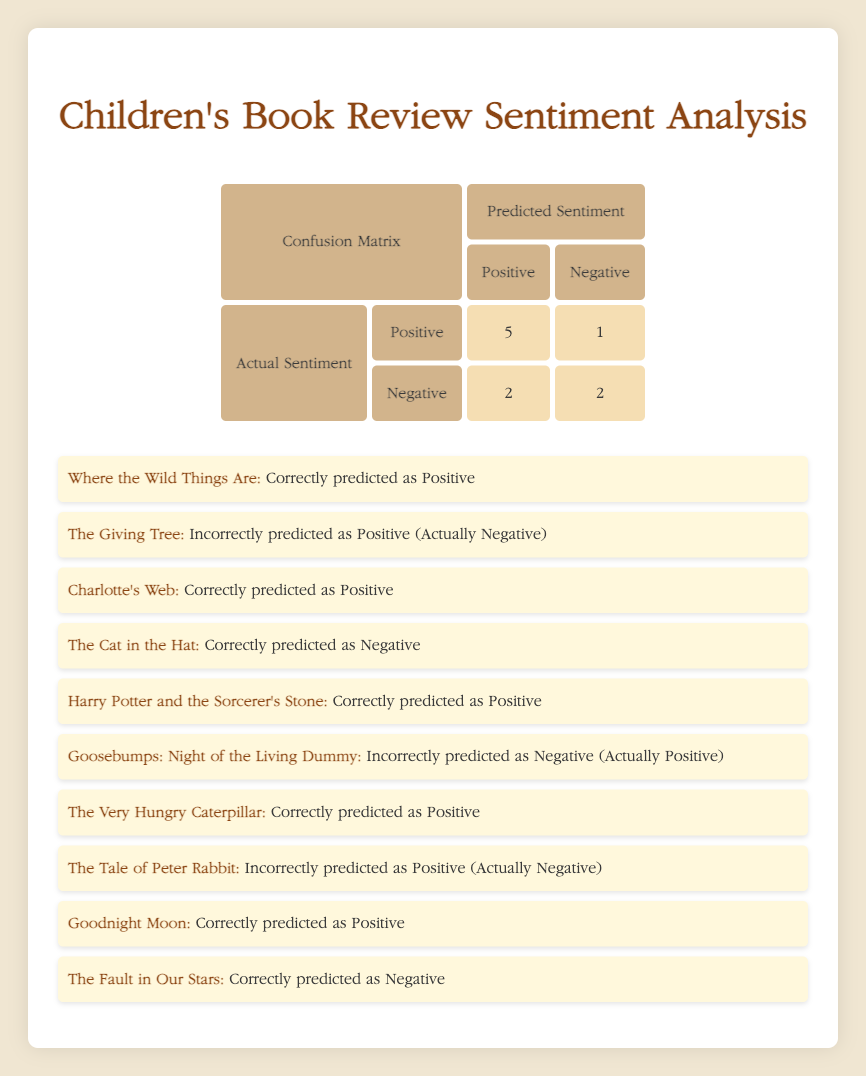What is the number of true positives in the confusion matrix? The confusion matrix shows 5 true positives, which means there are 5 instances where the predicted sentiment was positive and the actual sentiment was also positive.
Answer: 5 How many books were incorrectly predicted as having a positive sentiment? From the table, there are 2 instances where the actual sentiment was negative but predicted sentiment was positive: The Giving Tree and The Tale of Peter Rabbit.
Answer: 2 What is the total number of negative reviews? Looking at the "Actual Sentiment" row for Negative, there are 2 true negatives and 2 false negatives, resulting in a total of 2 actual negative reviews.
Answer: 2 Did any book receive a correct negative prediction? The Cat in the Hat and The Fault in Our Stars were both correctly predicted as negative, so yes, they did.
Answer: Yes What is the percentage of correct predictions overall? There are a total of 10 reviews, with 7 correct predictions (5 true positives and 2 true negatives). To find the percentage, calculate (7/10) * 100 = 70%.
Answer: 70% How many books correctly predicted as positive were actually negative? There are 2 instances: The Giving Tree and The Tale of Peter Rabbit, which were predicted to be positive but were actually negative.
Answer: 2 What is the difference between the number of true positives and true negatives? True positives are 5, and true negatives are 2. The difference is 5 - 2 = 3.
Answer: 3 How many books were reviewed in total? By counting all review IDs provided, the total reaches 10.
Answer: 10 